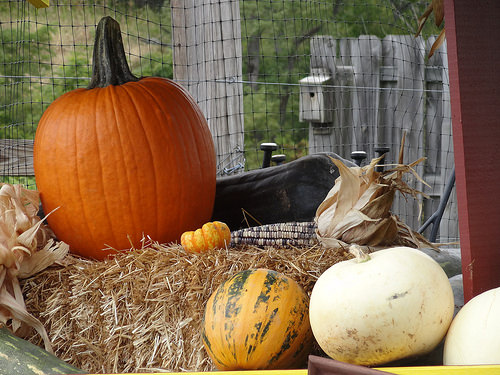<image>
Is there a pumpkin above the pumpkin? No. The pumpkin is not positioned above the pumpkin. The vertical arrangement shows a different relationship. 